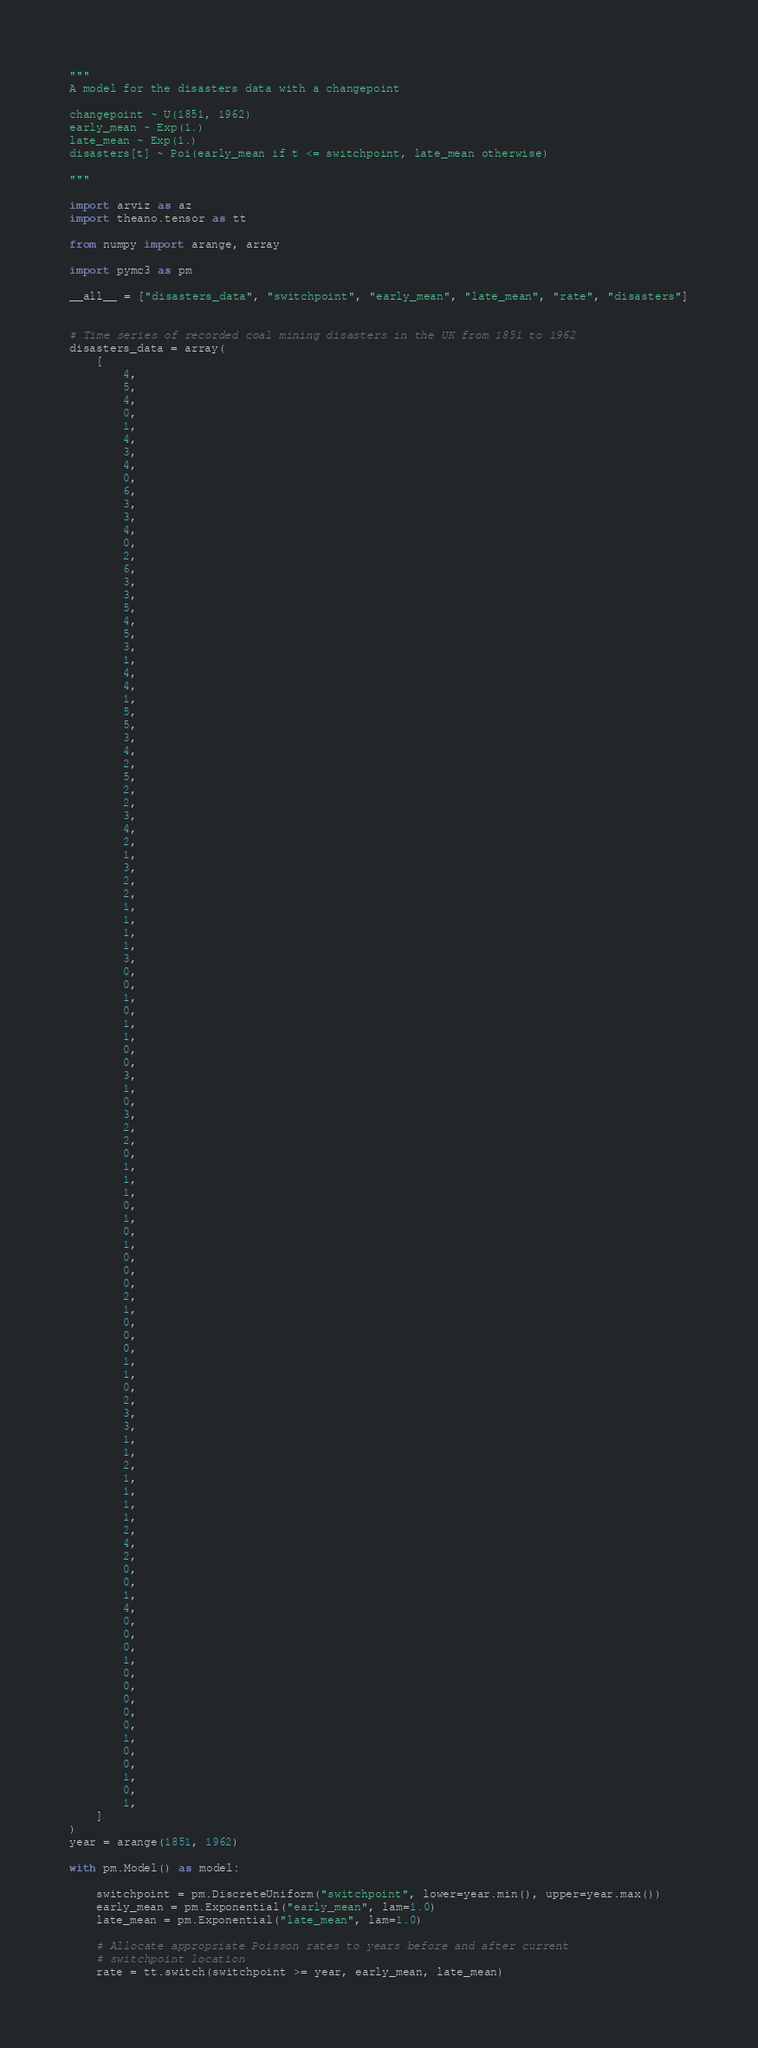Convert code to text. <code><loc_0><loc_0><loc_500><loc_500><_Python_>"""
A model for the disasters data with a changepoint

changepoint ~ U(1851, 1962)
early_mean ~ Exp(1.)
late_mean ~ Exp(1.)
disasters[t] ~ Poi(early_mean if t <= switchpoint, late_mean otherwise)

"""

import arviz as az
import theano.tensor as tt

from numpy import arange, array

import pymc3 as pm

__all__ = ["disasters_data", "switchpoint", "early_mean", "late_mean", "rate", "disasters"]


# Time series of recorded coal mining disasters in the UK from 1851 to 1962
disasters_data = array(
    [
        4,
        5,
        4,
        0,
        1,
        4,
        3,
        4,
        0,
        6,
        3,
        3,
        4,
        0,
        2,
        6,
        3,
        3,
        5,
        4,
        5,
        3,
        1,
        4,
        4,
        1,
        5,
        5,
        3,
        4,
        2,
        5,
        2,
        2,
        3,
        4,
        2,
        1,
        3,
        2,
        2,
        1,
        1,
        1,
        1,
        3,
        0,
        0,
        1,
        0,
        1,
        1,
        0,
        0,
        3,
        1,
        0,
        3,
        2,
        2,
        0,
        1,
        1,
        1,
        0,
        1,
        0,
        1,
        0,
        0,
        0,
        2,
        1,
        0,
        0,
        0,
        1,
        1,
        0,
        2,
        3,
        3,
        1,
        1,
        2,
        1,
        1,
        1,
        1,
        2,
        4,
        2,
        0,
        0,
        1,
        4,
        0,
        0,
        0,
        1,
        0,
        0,
        0,
        0,
        0,
        1,
        0,
        0,
        1,
        0,
        1,
    ]
)
year = arange(1851, 1962)

with pm.Model() as model:

    switchpoint = pm.DiscreteUniform("switchpoint", lower=year.min(), upper=year.max())
    early_mean = pm.Exponential("early_mean", lam=1.0)
    late_mean = pm.Exponential("late_mean", lam=1.0)

    # Allocate appropriate Poisson rates to years before and after current
    # switchpoint location
    rate = tt.switch(switchpoint >= year, early_mean, late_mean)
</code> 